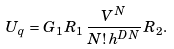Convert formula to latex. <formula><loc_0><loc_0><loc_500><loc_500>U _ { q } = G _ { 1 } \, R _ { 1 } \, \frac { V ^ { N } } { N ! \, h ^ { D N } } \, R _ { 2 } .</formula> 